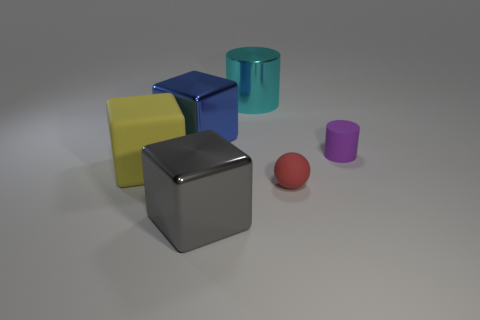Add 3 large yellow matte cylinders. How many objects exist? 9 Subtract all balls. How many objects are left? 5 Subtract 1 yellow blocks. How many objects are left? 5 Subtract all purple metallic objects. Subtract all purple cylinders. How many objects are left? 5 Add 1 small matte objects. How many small matte objects are left? 3 Add 6 yellow metallic cylinders. How many yellow metallic cylinders exist? 6 